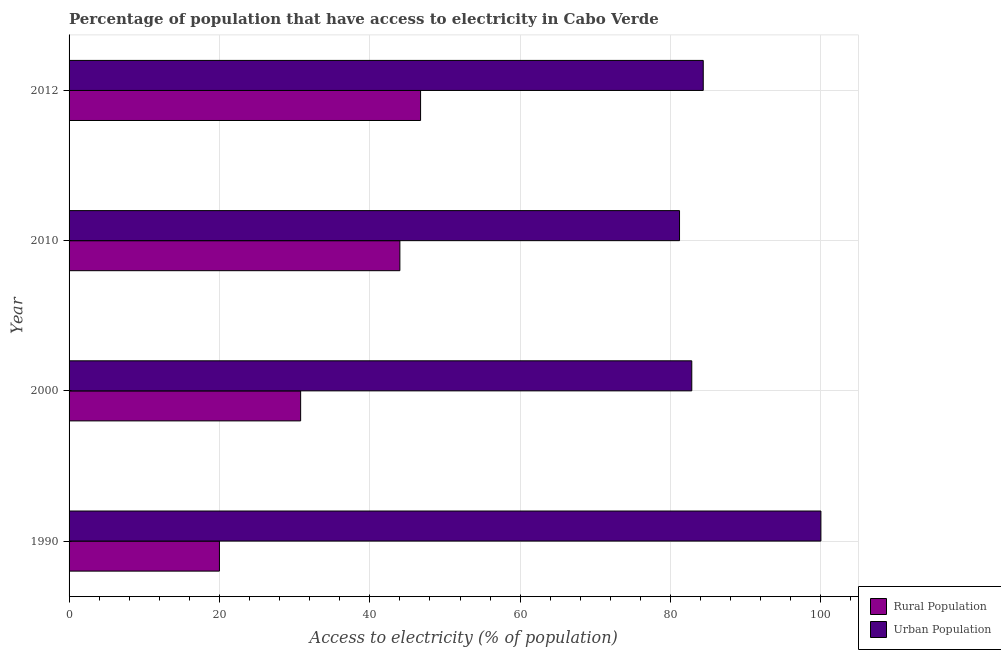How many groups of bars are there?
Keep it short and to the point. 4. Are the number of bars per tick equal to the number of legend labels?
Your response must be concise. Yes. How many bars are there on the 2nd tick from the top?
Provide a succinct answer. 2. How many bars are there on the 4th tick from the bottom?
Make the answer very short. 2. What is the percentage of urban population having access to electricity in 2000?
Your answer should be very brief. 82.83. Across all years, what is the minimum percentage of rural population having access to electricity?
Ensure brevity in your answer.  20. In which year was the percentage of urban population having access to electricity minimum?
Your answer should be compact. 2010. What is the total percentage of urban population having access to electricity in the graph?
Your answer should be compact. 348.37. What is the difference between the percentage of urban population having access to electricity in 2010 and that in 2012?
Ensure brevity in your answer.  -3.15. What is the difference between the percentage of rural population having access to electricity in 2012 and the percentage of urban population having access to electricity in 2010?
Your answer should be compact. -34.44. What is the average percentage of rural population having access to electricity per year?
Your response must be concise. 35.39. In the year 2012, what is the difference between the percentage of urban population having access to electricity and percentage of rural population having access to electricity?
Provide a short and direct response. 37.6. In how many years, is the percentage of urban population having access to electricity greater than 52 %?
Ensure brevity in your answer.  4. What is the ratio of the percentage of urban population having access to electricity in 1990 to that in 2000?
Offer a very short reply. 1.21. Is the percentage of urban population having access to electricity in 1990 less than that in 2010?
Your answer should be compact. No. Is the difference between the percentage of urban population having access to electricity in 2000 and 2012 greater than the difference between the percentage of rural population having access to electricity in 2000 and 2012?
Your response must be concise. Yes. What is the difference between the highest and the second highest percentage of urban population having access to electricity?
Offer a terse response. 15.65. Is the sum of the percentage of urban population having access to electricity in 2000 and 2012 greater than the maximum percentage of rural population having access to electricity across all years?
Ensure brevity in your answer.  Yes. What does the 2nd bar from the top in 2000 represents?
Make the answer very short. Rural Population. What does the 2nd bar from the bottom in 2010 represents?
Your answer should be very brief. Urban Population. How many bars are there?
Your response must be concise. 8. Does the graph contain grids?
Make the answer very short. Yes. Where does the legend appear in the graph?
Provide a succinct answer. Bottom right. How are the legend labels stacked?
Keep it short and to the point. Vertical. What is the title of the graph?
Keep it short and to the point. Percentage of population that have access to electricity in Cabo Verde. What is the label or title of the X-axis?
Provide a succinct answer. Access to electricity (% of population). What is the label or title of the Y-axis?
Your answer should be compact. Year. What is the Access to electricity (% of population) in Rural Population in 1990?
Your answer should be compact. 20. What is the Access to electricity (% of population) of Rural Population in 2000?
Your answer should be compact. 30.8. What is the Access to electricity (% of population) in Urban Population in 2000?
Offer a very short reply. 82.83. What is the Access to electricity (% of population) of Urban Population in 2010?
Your answer should be compact. 81.2. What is the Access to electricity (% of population) of Rural Population in 2012?
Provide a short and direct response. 46.75. What is the Access to electricity (% of population) of Urban Population in 2012?
Ensure brevity in your answer.  84.35. Across all years, what is the maximum Access to electricity (% of population) in Rural Population?
Your answer should be compact. 46.75. Across all years, what is the minimum Access to electricity (% of population) in Rural Population?
Make the answer very short. 20. Across all years, what is the minimum Access to electricity (% of population) in Urban Population?
Keep it short and to the point. 81.2. What is the total Access to electricity (% of population) of Rural Population in the graph?
Your answer should be very brief. 141.55. What is the total Access to electricity (% of population) in Urban Population in the graph?
Ensure brevity in your answer.  348.37. What is the difference between the Access to electricity (% of population) of Urban Population in 1990 and that in 2000?
Provide a succinct answer. 17.17. What is the difference between the Access to electricity (% of population) in Rural Population in 1990 and that in 2010?
Ensure brevity in your answer.  -24. What is the difference between the Access to electricity (% of population) of Urban Population in 1990 and that in 2010?
Your answer should be very brief. 18.8. What is the difference between the Access to electricity (% of population) of Rural Population in 1990 and that in 2012?
Keep it short and to the point. -26.75. What is the difference between the Access to electricity (% of population) in Urban Population in 1990 and that in 2012?
Offer a terse response. 15.65. What is the difference between the Access to electricity (% of population) of Urban Population in 2000 and that in 2010?
Make the answer very short. 1.63. What is the difference between the Access to electricity (% of population) in Rural Population in 2000 and that in 2012?
Your response must be concise. -15.95. What is the difference between the Access to electricity (% of population) in Urban Population in 2000 and that in 2012?
Your answer should be very brief. -1.53. What is the difference between the Access to electricity (% of population) in Rural Population in 2010 and that in 2012?
Ensure brevity in your answer.  -2.75. What is the difference between the Access to electricity (% of population) in Urban Population in 2010 and that in 2012?
Offer a very short reply. -3.15. What is the difference between the Access to electricity (% of population) of Rural Population in 1990 and the Access to electricity (% of population) of Urban Population in 2000?
Your response must be concise. -62.83. What is the difference between the Access to electricity (% of population) in Rural Population in 1990 and the Access to electricity (% of population) in Urban Population in 2010?
Ensure brevity in your answer.  -61.2. What is the difference between the Access to electricity (% of population) of Rural Population in 1990 and the Access to electricity (% of population) of Urban Population in 2012?
Provide a short and direct response. -64.35. What is the difference between the Access to electricity (% of population) of Rural Population in 2000 and the Access to electricity (% of population) of Urban Population in 2010?
Give a very brief answer. -50.4. What is the difference between the Access to electricity (% of population) of Rural Population in 2000 and the Access to electricity (% of population) of Urban Population in 2012?
Offer a terse response. -53.55. What is the difference between the Access to electricity (% of population) of Rural Population in 2010 and the Access to electricity (% of population) of Urban Population in 2012?
Give a very brief answer. -40.35. What is the average Access to electricity (% of population) in Rural Population per year?
Keep it short and to the point. 35.39. What is the average Access to electricity (% of population) in Urban Population per year?
Provide a short and direct response. 87.09. In the year 1990, what is the difference between the Access to electricity (% of population) in Rural Population and Access to electricity (% of population) in Urban Population?
Provide a short and direct response. -80. In the year 2000, what is the difference between the Access to electricity (% of population) in Rural Population and Access to electricity (% of population) in Urban Population?
Your answer should be compact. -52.03. In the year 2010, what is the difference between the Access to electricity (% of population) in Rural Population and Access to electricity (% of population) in Urban Population?
Provide a short and direct response. -37.2. In the year 2012, what is the difference between the Access to electricity (% of population) of Rural Population and Access to electricity (% of population) of Urban Population?
Offer a terse response. -37.6. What is the ratio of the Access to electricity (% of population) of Rural Population in 1990 to that in 2000?
Offer a terse response. 0.65. What is the ratio of the Access to electricity (% of population) of Urban Population in 1990 to that in 2000?
Ensure brevity in your answer.  1.21. What is the ratio of the Access to electricity (% of population) in Rural Population in 1990 to that in 2010?
Provide a succinct answer. 0.45. What is the ratio of the Access to electricity (% of population) in Urban Population in 1990 to that in 2010?
Offer a very short reply. 1.23. What is the ratio of the Access to electricity (% of population) of Rural Population in 1990 to that in 2012?
Ensure brevity in your answer.  0.43. What is the ratio of the Access to electricity (% of population) in Urban Population in 1990 to that in 2012?
Provide a succinct answer. 1.19. What is the ratio of the Access to electricity (% of population) in Rural Population in 2000 to that in 2010?
Give a very brief answer. 0.7. What is the ratio of the Access to electricity (% of population) in Urban Population in 2000 to that in 2010?
Your answer should be very brief. 1.02. What is the ratio of the Access to electricity (% of population) of Rural Population in 2000 to that in 2012?
Offer a terse response. 0.66. What is the ratio of the Access to electricity (% of population) in Urban Population in 2000 to that in 2012?
Ensure brevity in your answer.  0.98. What is the ratio of the Access to electricity (% of population) in Rural Population in 2010 to that in 2012?
Offer a terse response. 0.94. What is the ratio of the Access to electricity (% of population) of Urban Population in 2010 to that in 2012?
Your response must be concise. 0.96. What is the difference between the highest and the second highest Access to electricity (% of population) of Rural Population?
Give a very brief answer. 2.75. What is the difference between the highest and the second highest Access to electricity (% of population) of Urban Population?
Your answer should be compact. 15.65. What is the difference between the highest and the lowest Access to electricity (% of population) of Rural Population?
Give a very brief answer. 26.75. What is the difference between the highest and the lowest Access to electricity (% of population) of Urban Population?
Give a very brief answer. 18.8. 